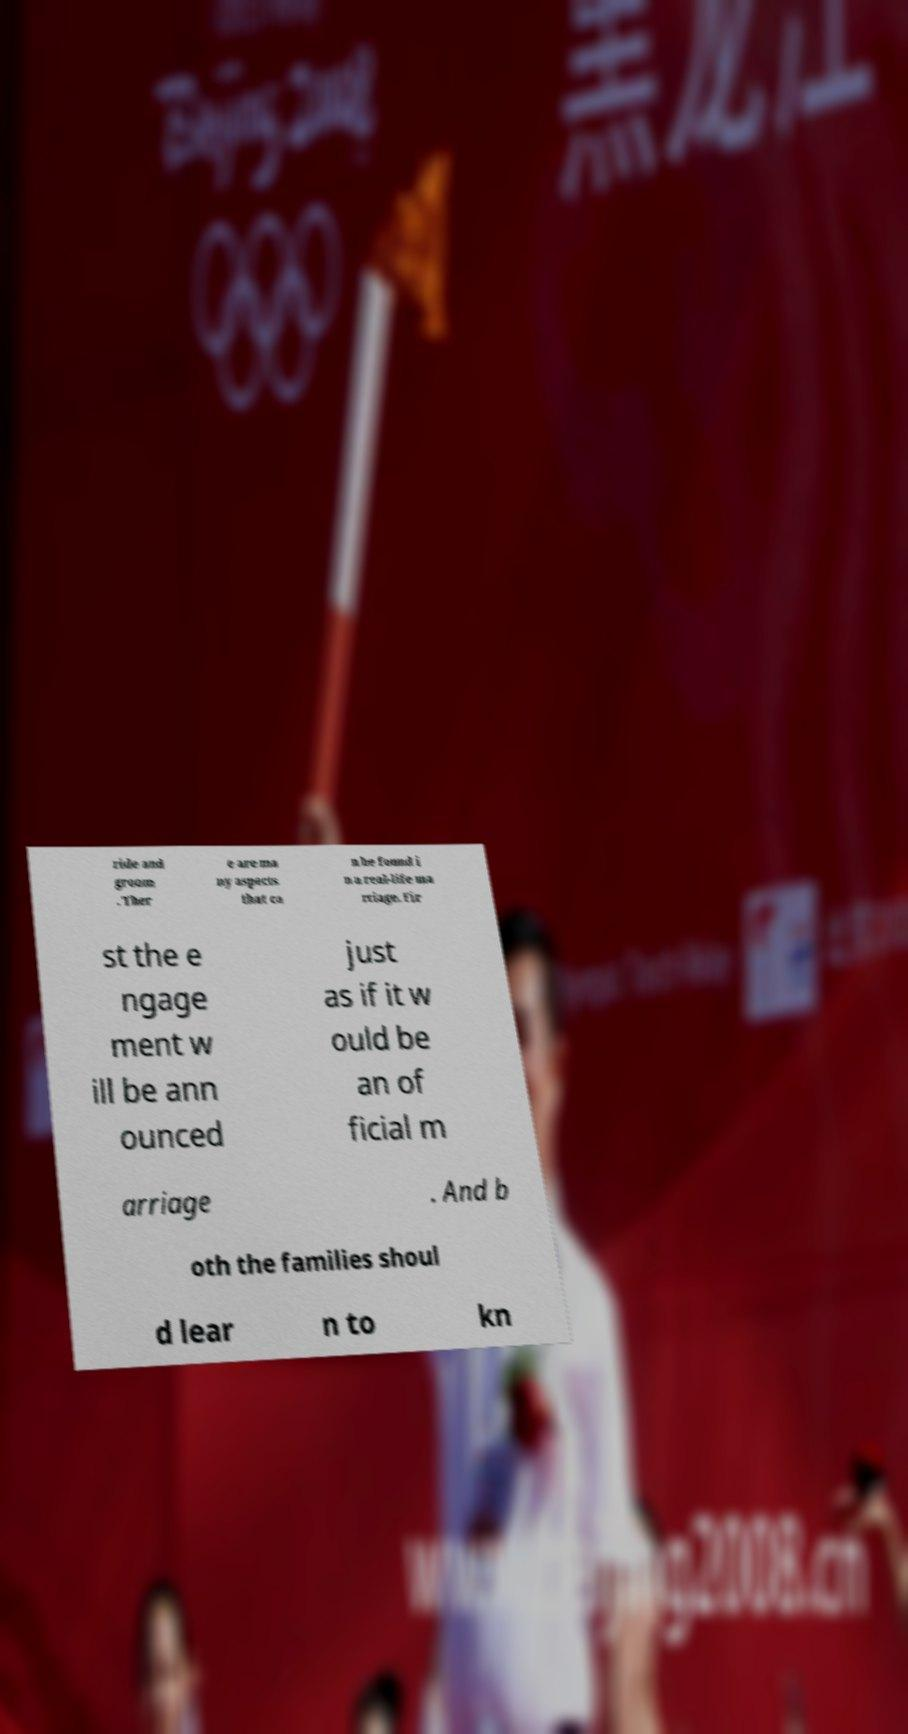Can you accurately transcribe the text from the provided image for me? ride and groom . Ther e are ma ny aspects that ca n be found i n a real-life ma rriage. Fir st the e ngage ment w ill be ann ounced just as if it w ould be an of ficial m arriage . And b oth the families shoul d lear n to kn 